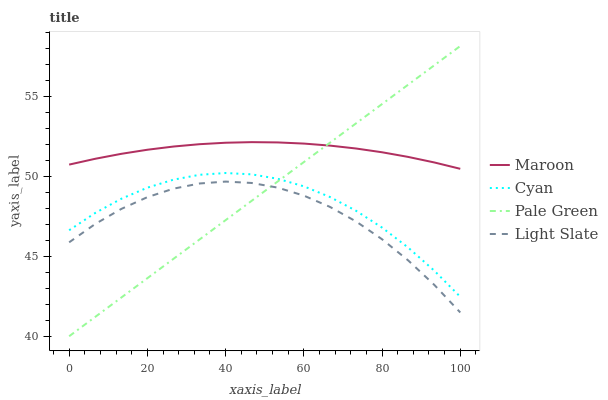Does Light Slate have the minimum area under the curve?
Answer yes or no. Yes. Does Maroon have the maximum area under the curve?
Answer yes or no. Yes. Does Cyan have the minimum area under the curve?
Answer yes or no. No. Does Cyan have the maximum area under the curve?
Answer yes or no. No. Is Pale Green the smoothest?
Answer yes or no. Yes. Is Light Slate the roughest?
Answer yes or no. Yes. Is Cyan the smoothest?
Answer yes or no. No. Is Cyan the roughest?
Answer yes or no. No. Does Cyan have the lowest value?
Answer yes or no. No. Does Pale Green have the highest value?
Answer yes or no. Yes. Does Cyan have the highest value?
Answer yes or no. No. Is Cyan less than Maroon?
Answer yes or no. Yes. Is Cyan greater than Light Slate?
Answer yes or no. Yes. Does Pale Green intersect Light Slate?
Answer yes or no. Yes. Is Pale Green less than Light Slate?
Answer yes or no. No. Is Pale Green greater than Light Slate?
Answer yes or no. No. Does Cyan intersect Maroon?
Answer yes or no. No. 